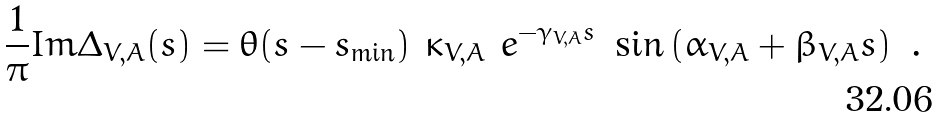<formula> <loc_0><loc_0><loc_500><loc_500>\frac { 1 } { \pi } I m \Delta _ { V , A } ( s ) = \theta ( s - s _ { \min } ) \ \kappa _ { V , A } \ e ^ { - \gamma _ { V , A } s } \ \sin \left ( \alpha _ { V , A } + \beta _ { V , A } s \right ) \ .</formula> 